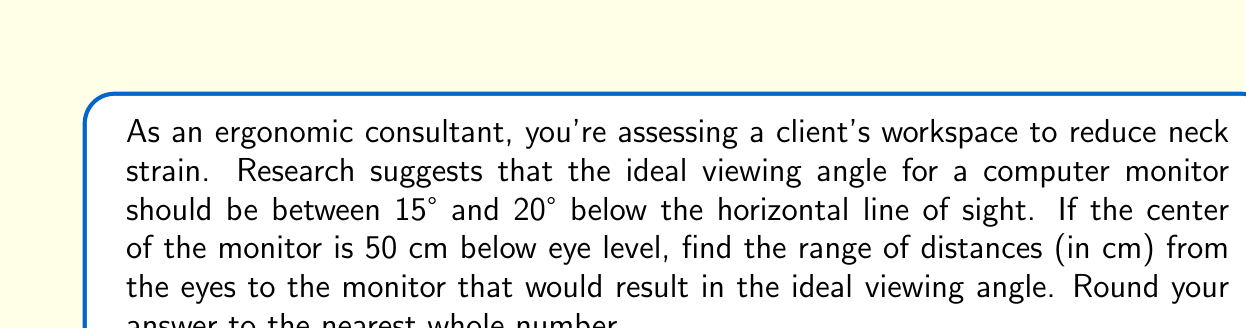Can you answer this question? Let's approach this step-by-step:

1) We can use trigonometry to solve this problem. The viewing angle forms a right triangle with the vertical distance from eye level to the monitor center and the horizontal distance from the eyes to the monitor.

2) Let's define our variables:
   $\theta$ = viewing angle
   $y$ = vertical distance (given as 50 cm)
   $x$ = horizontal distance (what we're solving for)

3) We can use the tangent function to relate these variables:

   $$\tan(\theta) = \frac{y}{x}$$

4) We need to solve this for two angles: 15° and 20°, which will give us our range.

5) For 15°:
   $$\tan(15°) = \frac{50}{x}$$
   $$x = \frac{50}{\tan(15°)} \approx 186.4 \text{ cm}$$

6) For 20°:
   $$\tan(20°) = \frac{50}{x}$$
   $$x = \frac{50}{\tan(20°)} \approx 137.4 \text{ cm}$$

7) Rounding to the nearest whole number:
   The range is approximately 137 cm to 186 cm.
Answer: The ideal range of distances from the eyes to the monitor is approximately 137 cm to 186 cm. 